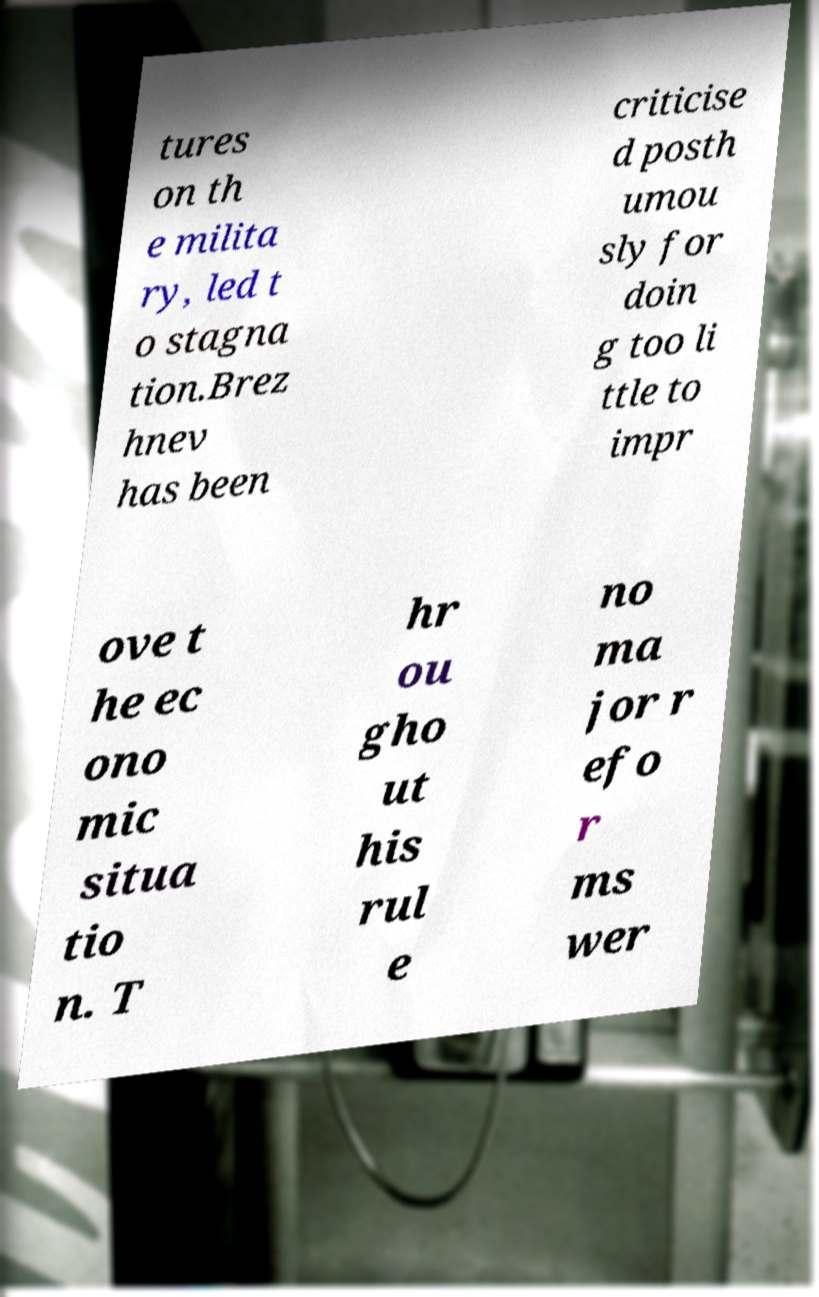For documentation purposes, I need the text within this image transcribed. Could you provide that? tures on th e milita ry, led t o stagna tion.Brez hnev has been criticise d posth umou sly for doin g too li ttle to impr ove t he ec ono mic situa tio n. T hr ou gho ut his rul e no ma jor r efo r ms wer 